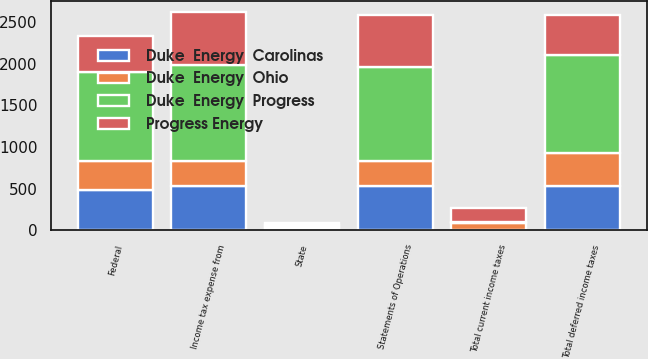Convert chart to OTSL. <chart><loc_0><loc_0><loc_500><loc_500><stacked_bar_chart><ecel><fcel>State<fcel>Total current income taxes<fcel>Federal<fcel>Total deferred income taxes<fcel>Income tax expense from<fcel>Statements of Operations<nl><fcel>Duke  Energy  Progress<fcel>15<fcel>13<fcel>1064<fcel>1181<fcel>1156<fcel>1126<nl><fcel>Progress Energy<fcel>25<fcel>164<fcel>430<fcel>475<fcel>634<fcel>634<nl><fcel>Duke  Energy  Carolinas<fcel>19<fcel>4<fcel>486<fcel>536<fcel>527<fcel>528<nl><fcel>Duke  Energy  Ohio<fcel>25<fcel>84<fcel>350<fcel>390<fcel>301<fcel>301<nl></chart> 